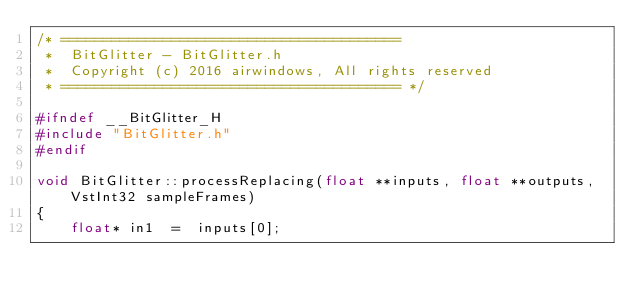<code> <loc_0><loc_0><loc_500><loc_500><_C++_>/* ========================================
 *  BitGlitter - BitGlitter.h
 *  Copyright (c) 2016 airwindows, All rights reserved
 * ======================================== */

#ifndef __BitGlitter_H
#include "BitGlitter.h"
#endif

void BitGlitter::processReplacing(float **inputs, float **outputs, VstInt32 sampleFrames) 
{
    float* in1  =  inputs[0];</code> 